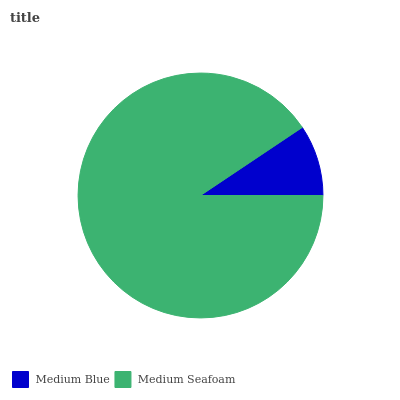Is Medium Blue the minimum?
Answer yes or no. Yes. Is Medium Seafoam the maximum?
Answer yes or no. Yes. Is Medium Seafoam the minimum?
Answer yes or no. No. Is Medium Seafoam greater than Medium Blue?
Answer yes or no. Yes. Is Medium Blue less than Medium Seafoam?
Answer yes or no. Yes. Is Medium Blue greater than Medium Seafoam?
Answer yes or no. No. Is Medium Seafoam less than Medium Blue?
Answer yes or no. No. Is Medium Seafoam the high median?
Answer yes or no. Yes. Is Medium Blue the low median?
Answer yes or no. Yes. Is Medium Blue the high median?
Answer yes or no. No. Is Medium Seafoam the low median?
Answer yes or no. No. 